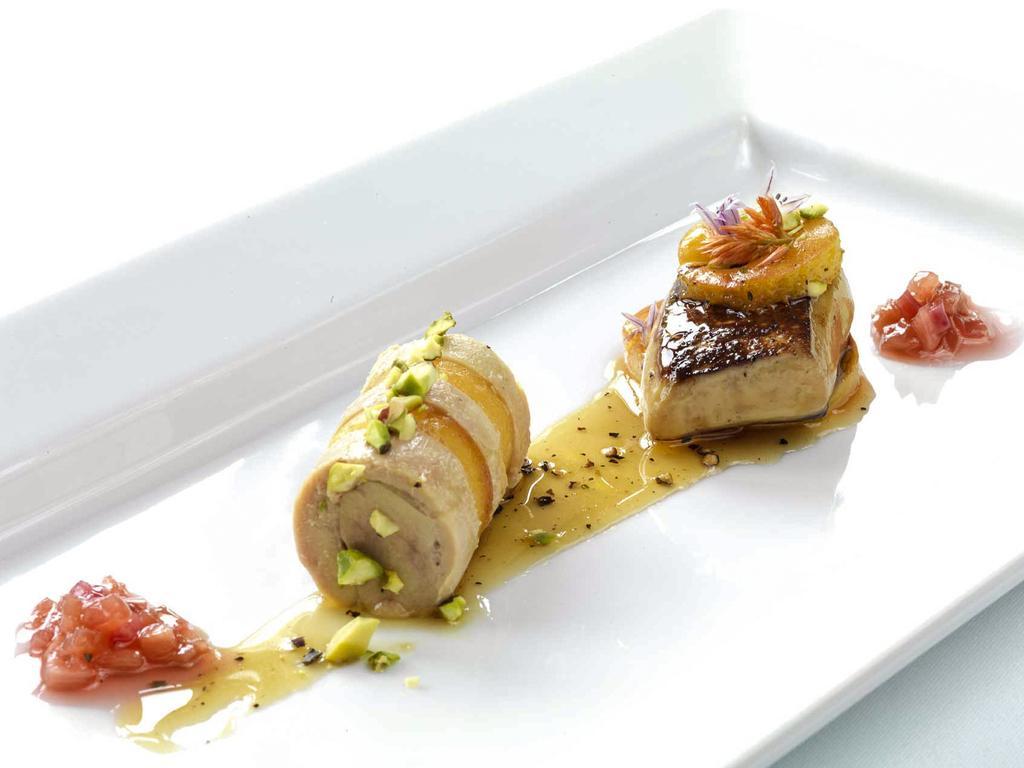How would you summarize this image in a sentence or two? In this image I can see the food in the white color plate. Food is in cream, red and brown color. 